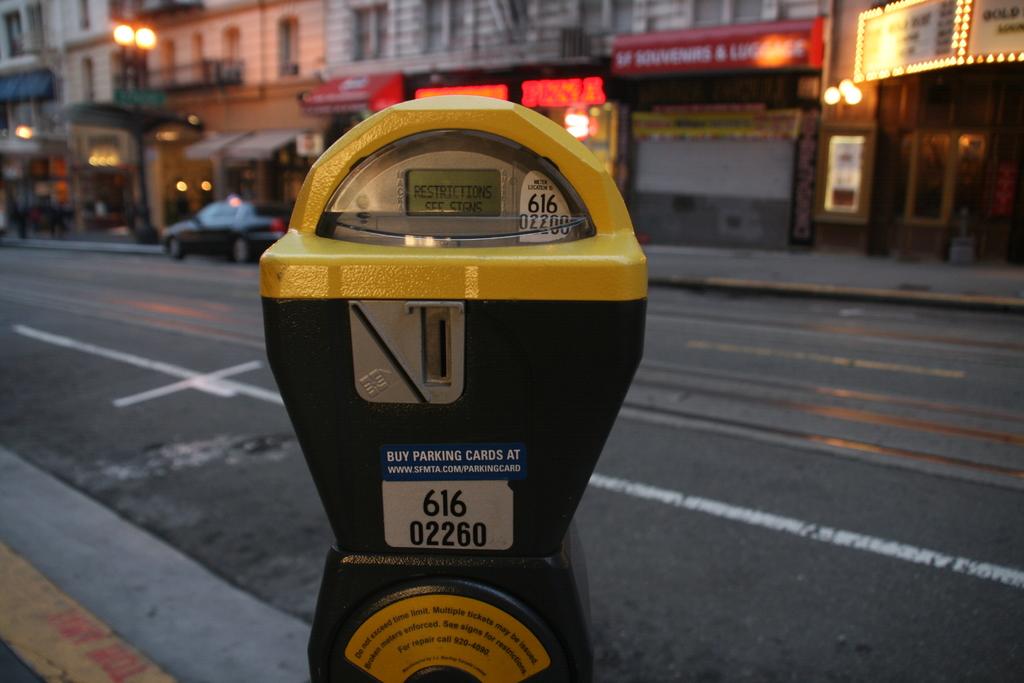What number parking meter is this?
Your answer should be very brief. 616 02260. What can you buy at the website listed on the blue label?
Offer a very short reply. Parking cards. 